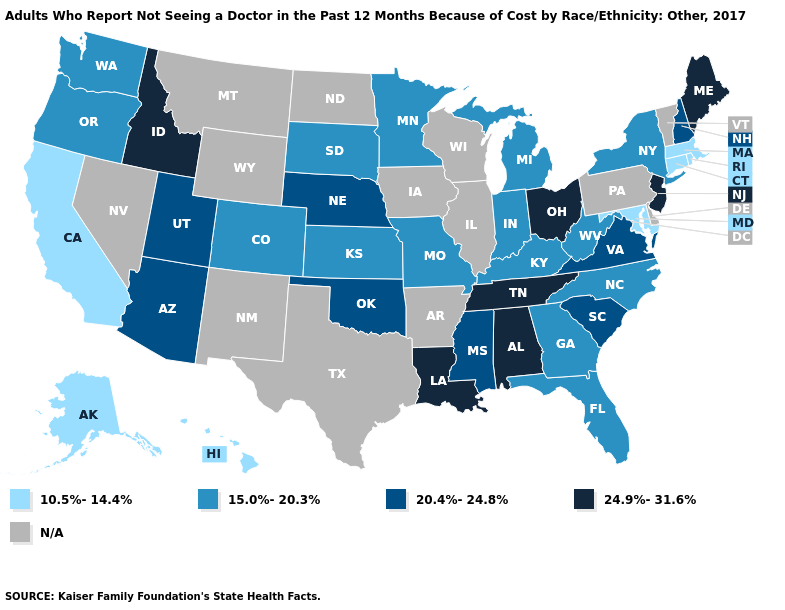What is the value of New Jersey?
Keep it brief. 24.9%-31.6%. Is the legend a continuous bar?
Write a very short answer. No. What is the lowest value in the West?
Concise answer only. 10.5%-14.4%. Name the states that have a value in the range N/A?
Keep it brief. Arkansas, Delaware, Illinois, Iowa, Montana, Nevada, New Mexico, North Dakota, Pennsylvania, Texas, Vermont, Wisconsin, Wyoming. Name the states that have a value in the range 20.4%-24.8%?
Short answer required. Arizona, Mississippi, Nebraska, New Hampshire, Oklahoma, South Carolina, Utah, Virginia. Does Connecticut have the lowest value in the USA?
Concise answer only. Yes. Does North Carolina have the lowest value in the USA?
Short answer required. No. What is the lowest value in the Northeast?
Give a very brief answer. 10.5%-14.4%. What is the value of Oregon?
Quick response, please. 15.0%-20.3%. What is the value of Utah?
Concise answer only. 20.4%-24.8%. What is the value of Oklahoma?
Answer briefly. 20.4%-24.8%. 